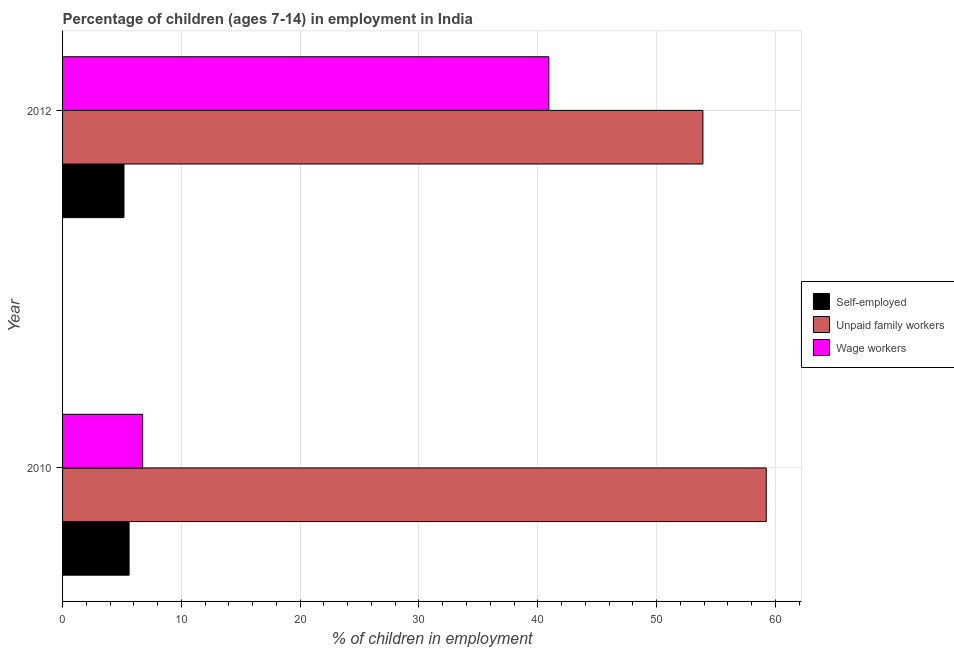How many different coloured bars are there?
Offer a very short reply. 3. Are the number of bars per tick equal to the number of legend labels?
Provide a succinct answer. Yes. How many bars are there on the 1st tick from the bottom?
Make the answer very short. 3. What is the percentage of children employed as wage workers in 2010?
Provide a short and direct response. 6.74. Across all years, what is the maximum percentage of children employed as unpaid family workers?
Offer a terse response. 59.23. Across all years, what is the minimum percentage of children employed as wage workers?
Offer a very short reply. 6.74. In which year was the percentage of self employed children minimum?
Provide a short and direct response. 2012. What is the total percentage of children employed as unpaid family workers in the graph?
Keep it short and to the point. 113.13. What is the difference between the percentage of children employed as wage workers in 2010 and that in 2012?
Make the answer very short. -34.19. What is the difference between the percentage of children employed as unpaid family workers in 2010 and the percentage of children employed as wage workers in 2012?
Offer a terse response. 18.3. What is the average percentage of children employed as wage workers per year?
Make the answer very short. 23.84. In the year 2010, what is the difference between the percentage of self employed children and percentage of children employed as unpaid family workers?
Give a very brief answer. -53.63. What is the ratio of the percentage of children employed as unpaid family workers in 2010 to that in 2012?
Give a very brief answer. 1.1. Is the percentage of self employed children in 2010 less than that in 2012?
Ensure brevity in your answer.  No. In how many years, is the percentage of self employed children greater than the average percentage of self employed children taken over all years?
Provide a short and direct response. 1. What does the 2nd bar from the top in 2010 represents?
Provide a succinct answer. Unpaid family workers. What does the 2nd bar from the bottom in 2010 represents?
Provide a short and direct response. Unpaid family workers. How many bars are there?
Your answer should be compact. 6. Are the values on the major ticks of X-axis written in scientific E-notation?
Make the answer very short. No. Does the graph contain any zero values?
Ensure brevity in your answer.  No. Where does the legend appear in the graph?
Provide a succinct answer. Center right. How many legend labels are there?
Offer a very short reply. 3. How are the legend labels stacked?
Make the answer very short. Vertical. What is the title of the graph?
Offer a terse response. Percentage of children (ages 7-14) in employment in India. What is the label or title of the X-axis?
Ensure brevity in your answer.  % of children in employment. What is the label or title of the Y-axis?
Ensure brevity in your answer.  Year. What is the % of children in employment of Self-employed in 2010?
Offer a terse response. 5.6. What is the % of children in employment of Unpaid family workers in 2010?
Give a very brief answer. 59.23. What is the % of children in employment in Wage workers in 2010?
Offer a terse response. 6.74. What is the % of children in employment in Self-employed in 2012?
Your response must be concise. 5.17. What is the % of children in employment in Unpaid family workers in 2012?
Provide a succinct answer. 53.9. What is the % of children in employment of Wage workers in 2012?
Provide a succinct answer. 40.93. Across all years, what is the maximum % of children in employment in Self-employed?
Provide a succinct answer. 5.6. Across all years, what is the maximum % of children in employment of Unpaid family workers?
Your answer should be very brief. 59.23. Across all years, what is the maximum % of children in employment of Wage workers?
Ensure brevity in your answer.  40.93. Across all years, what is the minimum % of children in employment of Self-employed?
Your answer should be very brief. 5.17. Across all years, what is the minimum % of children in employment of Unpaid family workers?
Offer a terse response. 53.9. Across all years, what is the minimum % of children in employment in Wage workers?
Your answer should be very brief. 6.74. What is the total % of children in employment of Self-employed in the graph?
Give a very brief answer. 10.77. What is the total % of children in employment of Unpaid family workers in the graph?
Your answer should be compact. 113.13. What is the total % of children in employment of Wage workers in the graph?
Provide a short and direct response. 47.67. What is the difference between the % of children in employment in Self-employed in 2010 and that in 2012?
Provide a short and direct response. 0.43. What is the difference between the % of children in employment in Unpaid family workers in 2010 and that in 2012?
Provide a short and direct response. 5.33. What is the difference between the % of children in employment of Wage workers in 2010 and that in 2012?
Offer a very short reply. -34.19. What is the difference between the % of children in employment of Self-employed in 2010 and the % of children in employment of Unpaid family workers in 2012?
Offer a very short reply. -48.3. What is the difference between the % of children in employment of Self-employed in 2010 and the % of children in employment of Wage workers in 2012?
Your response must be concise. -35.33. What is the average % of children in employment of Self-employed per year?
Your response must be concise. 5.38. What is the average % of children in employment of Unpaid family workers per year?
Make the answer very short. 56.56. What is the average % of children in employment of Wage workers per year?
Provide a succinct answer. 23.84. In the year 2010, what is the difference between the % of children in employment in Self-employed and % of children in employment in Unpaid family workers?
Keep it short and to the point. -53.63. In the year 2010, what is the difference between the % of children in employment of Self-employed and % of children in employment of Wage workers?
Your answer should be very brief. -1.14. In the year 2010, what is the difference between the % of children in employment of Unpaid family workers and % of children in employment of Wage workers?
Offer a terse response. 52.49. In the year 2012, what is the difference between the % of children in employment in Self-employed and % of children in employment in Unpaid family workers?
Give a very brief answer. -48.73. In the year 2012, what is the difference between the % of children in employment in Self-employed and % of children in employment in Wage workers?
Provide a succinct answer. -35.76. In the year 2012, what is the difference between the % of children in employment of Unpaid family workers and % of children in employment of Wage workers?
Provide a succinct answer. 12.97. What is the ratio of the % of children in employment in Self-employed in 2010 to that in 2012?
Your answer should be compact. 1.08. What is the ratio of the % of children in employment of Unpaid family workers in 2010 to that in 2012?
Your response must be concise. 1.1. What is the ratio of the % of children in employment in Wage workers in 2010 to that in 2012?
Make the answer very short. 0.16. What is the difference between the highest and the second highest % of children in employment in Self-employed?
Give a very brief answer. 0.43. What is the difference between the highest and the second highest % of children in employment in Unpaid family workers?
Make the answer very short. 5.33. What is the difference between the highest and the second highest % of children in employment of Wage workers?
Your answer should be compact. 34.19. What is the difference between the highest and the lowest % of children in employment of Self-employed?
Give a very brief answer. 0.43. What is the difference between the highest and the lowest % of children in employment of Unpaid family workers?
Provide a succinct answer. 5.33. What is the difference between the highest and the lowest % of children in employment in Wage workers?
Give a very brief answer. 34.19. 